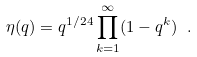<formula> <loc_0><loc_0><loc_500><loc_500>\eta ( q ) = q ^ { 1 / 2 4 } \prod _ { k = 1 } ^ { \infty } ( 1 - q ^ { k } ) \ .</formula> 